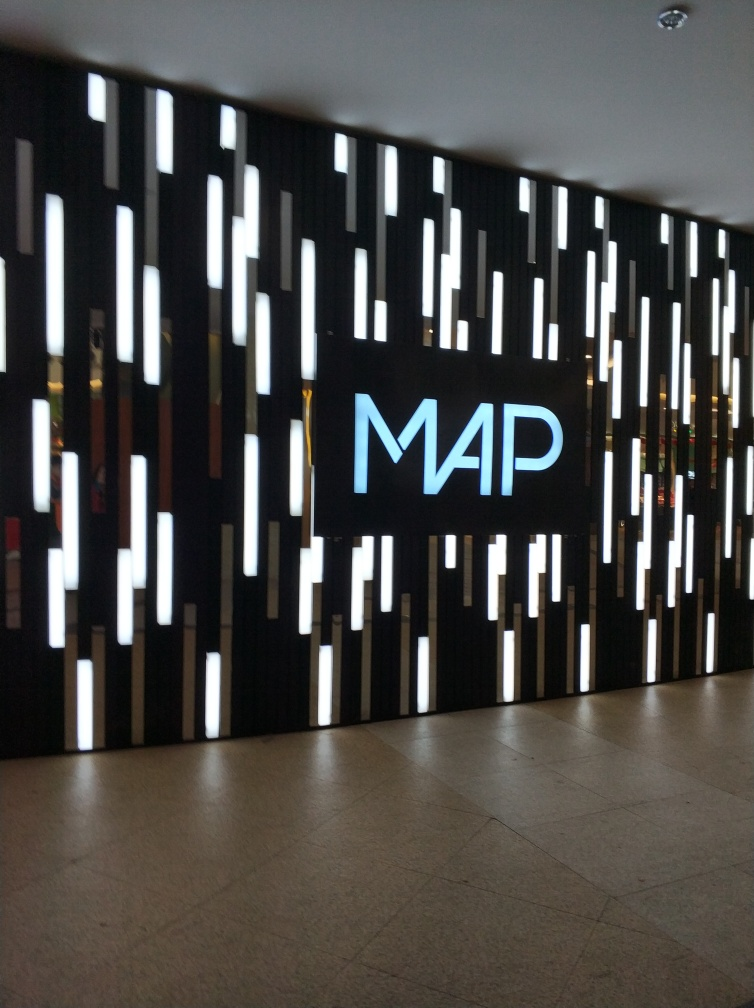Can you infer the type of establishment this wall design is located in? Based on the elegant lighting design and the prominent 'MAP' logo illuminated in the center, it is likely that this wall is part of a commercial establishment such as a high-end retail store, a modern art gallery, or the foyer of a company that values brand image and aesthetic appeal. Does the design seem to serve a practical purpose as well? Indeed, aside from its aesthetic value, the design might serve a practical purpose as well. It can function as ambient lighting to create a welcoming environment and may also serve as a guide, leading visitors towards a particular area or function as an indirect wayfinding element by highlighting the logo. 